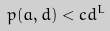Convert formula to latex. <formula><loc_0><loc_0><loc_500><loc_500>p ( a , d ) < c d ^ { L }</formula> 